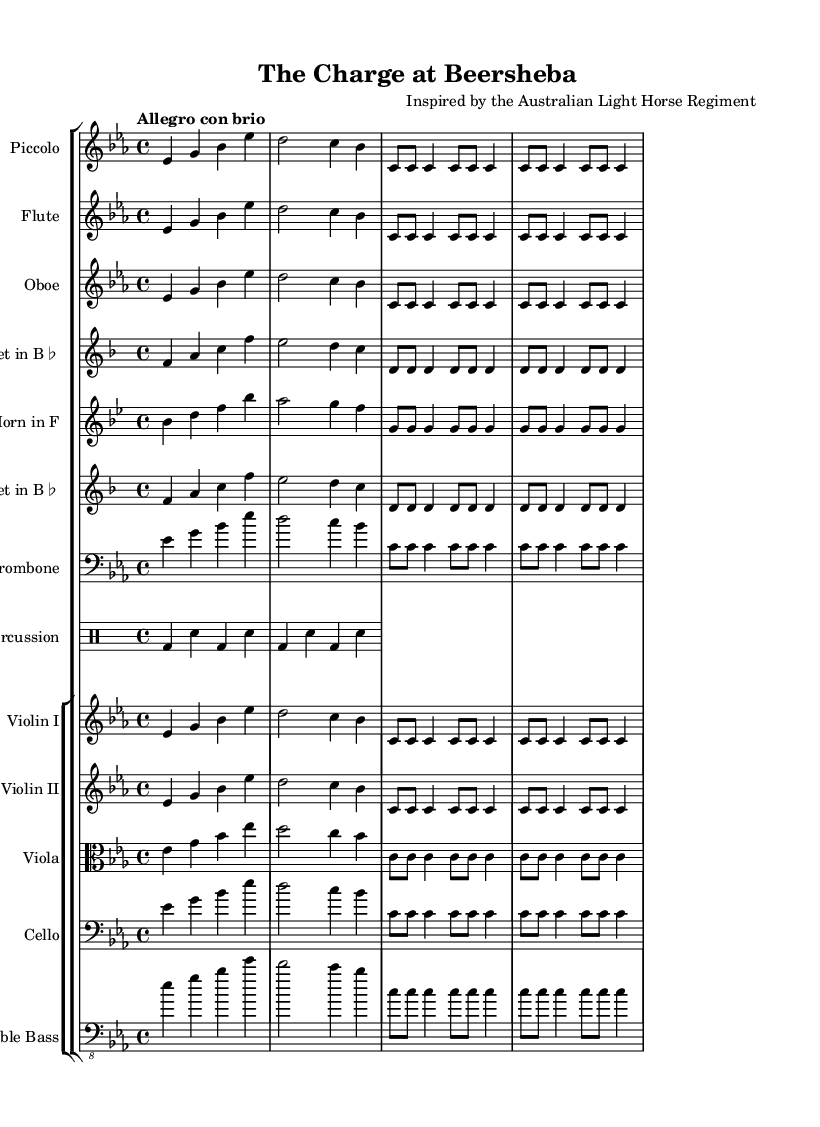What is the key signature of this music? The key signature is indicated by the number of sharps or flats at the beginning of the staff. In this piece, there are three flats (B♭, E♭, and A♭), which corresponds to E♭ major.
Answer: E♭ major What is the time signature of this music? The time signature is found at the beginning of the staff, represented as a fraction. Here, it is shown as 4/4, indicating four beats per measure and the quarter note receives one beat.
Answer: 4/4 What is the tempo marking of this piece? The tempo marking is typically described at the start of the music, specifying the speed. In this case, it is marked as "Allegro con brio," signifying a lively and brisk tempo.
Answer: Allegro con brio How many instruments are indicated in the score? The score includes multiple staves representing different instruments. Counting all unique staves, there are nine instruments noted, including woodwinds, brass, strings, and percussion.
Answer: Nine What is the primary theme's rhythmic motif? The rhythmic motif is identified by looking at the repeating patterns in the music. Here, the rhythmic motif consists of repeated eight and quarter notes, creating a driving rhythmic pulse.
Answer: c8 c c4 Which instrument plays the main theme in the score? The main theme is depicted in all the staves. However, notably, the Piccolo, Flute, and Violin I prominently feature it, illustrating its significance in the orchestration.
Answer: Piccolo 